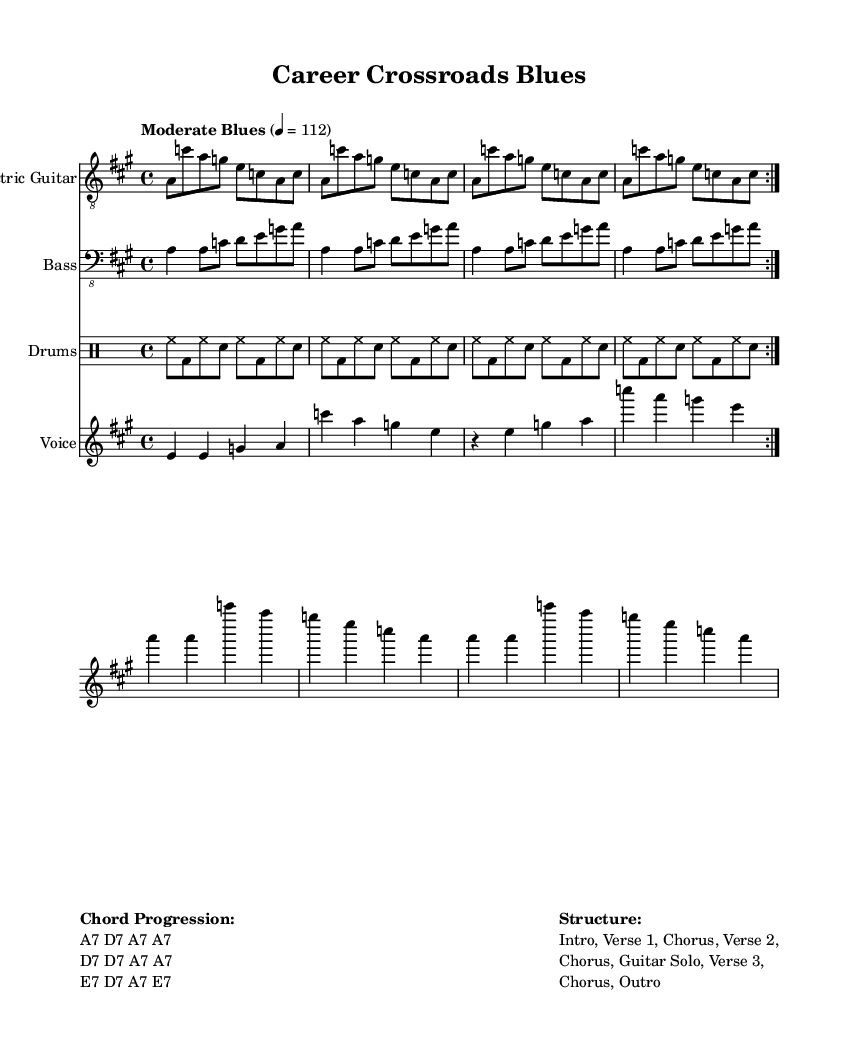What is the key signature of this music? The key signature is A major, which has three sharps (F#, C#, G#). This is indicated in the score by the sharp symbols on the staff lines corresponding to these notes.
Answer: A major What is the time signature of this sheet music? The time signature is 4/4, which means there are four beats in each measure and the quarter note receives one beat. This is shown in the beginning of the score.
Answer: 4/4 What is the tempo marking given in the score? The tempo marking is "Moderate Blues", indicating the style and speed of the music. Additionally, a metronome marking of 112 beats per minute suggests the speed at which the music should be played.
Answer: Moderate Blues How many verses are there in the structure of the song? The structure describes having three verses before it ends, as indicated by the listed components: Intro, Verse 1, Chorus, Verse 2, Chorus, Guitar Solo, Verse 3, and Chorus. Each verse corresponds to a different set of lyrics.
Answer: 3 What chord is used in the intro? The chord used in the intro is A7, as notated at the beginning of the chord progression. This is a typical chord for Electric Blues and sets the tonal center for the piece.
Answer: A7 What type of instrumentation is prominently featured in this piece? The prominent instrumentation includes Electric Guitar, Bass, and Drums, each with a dedicated staff in the score layout. This is characteristic of Electric Blues, where the guitar often plays a lead role and is supported by rhythm and bass sections.
Answer: Electric Guitar, Bass, Drums What is the lyrical theme of the song? The lyrical theme revolves around career changes and the post-college experience, indicated by the lyrics in the verse discussing unexpected life paths and "Post-college blues". This reflects common struggles faced by individuals transitioning from academics to the workforce.
Answer: Career transitions 